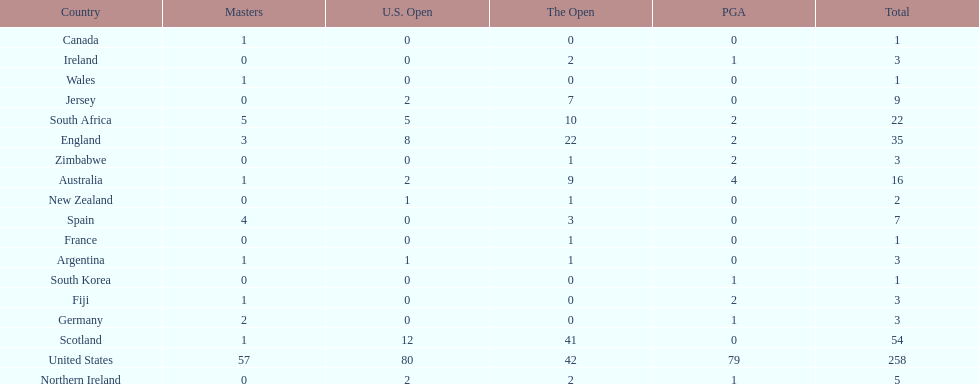How many countries have produced the same number of championship golfers as canada? 3. 